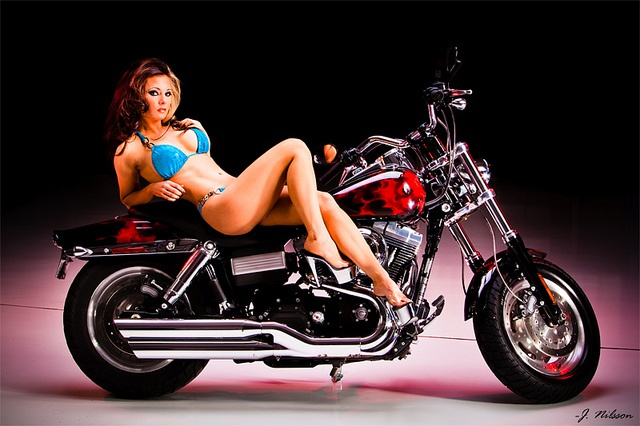Describe the objects in this image and their specific colors. I can see motorcycle in black, white, gray, and maroon tones and people in black, lightgray, salmon, and tan tones in this image. 